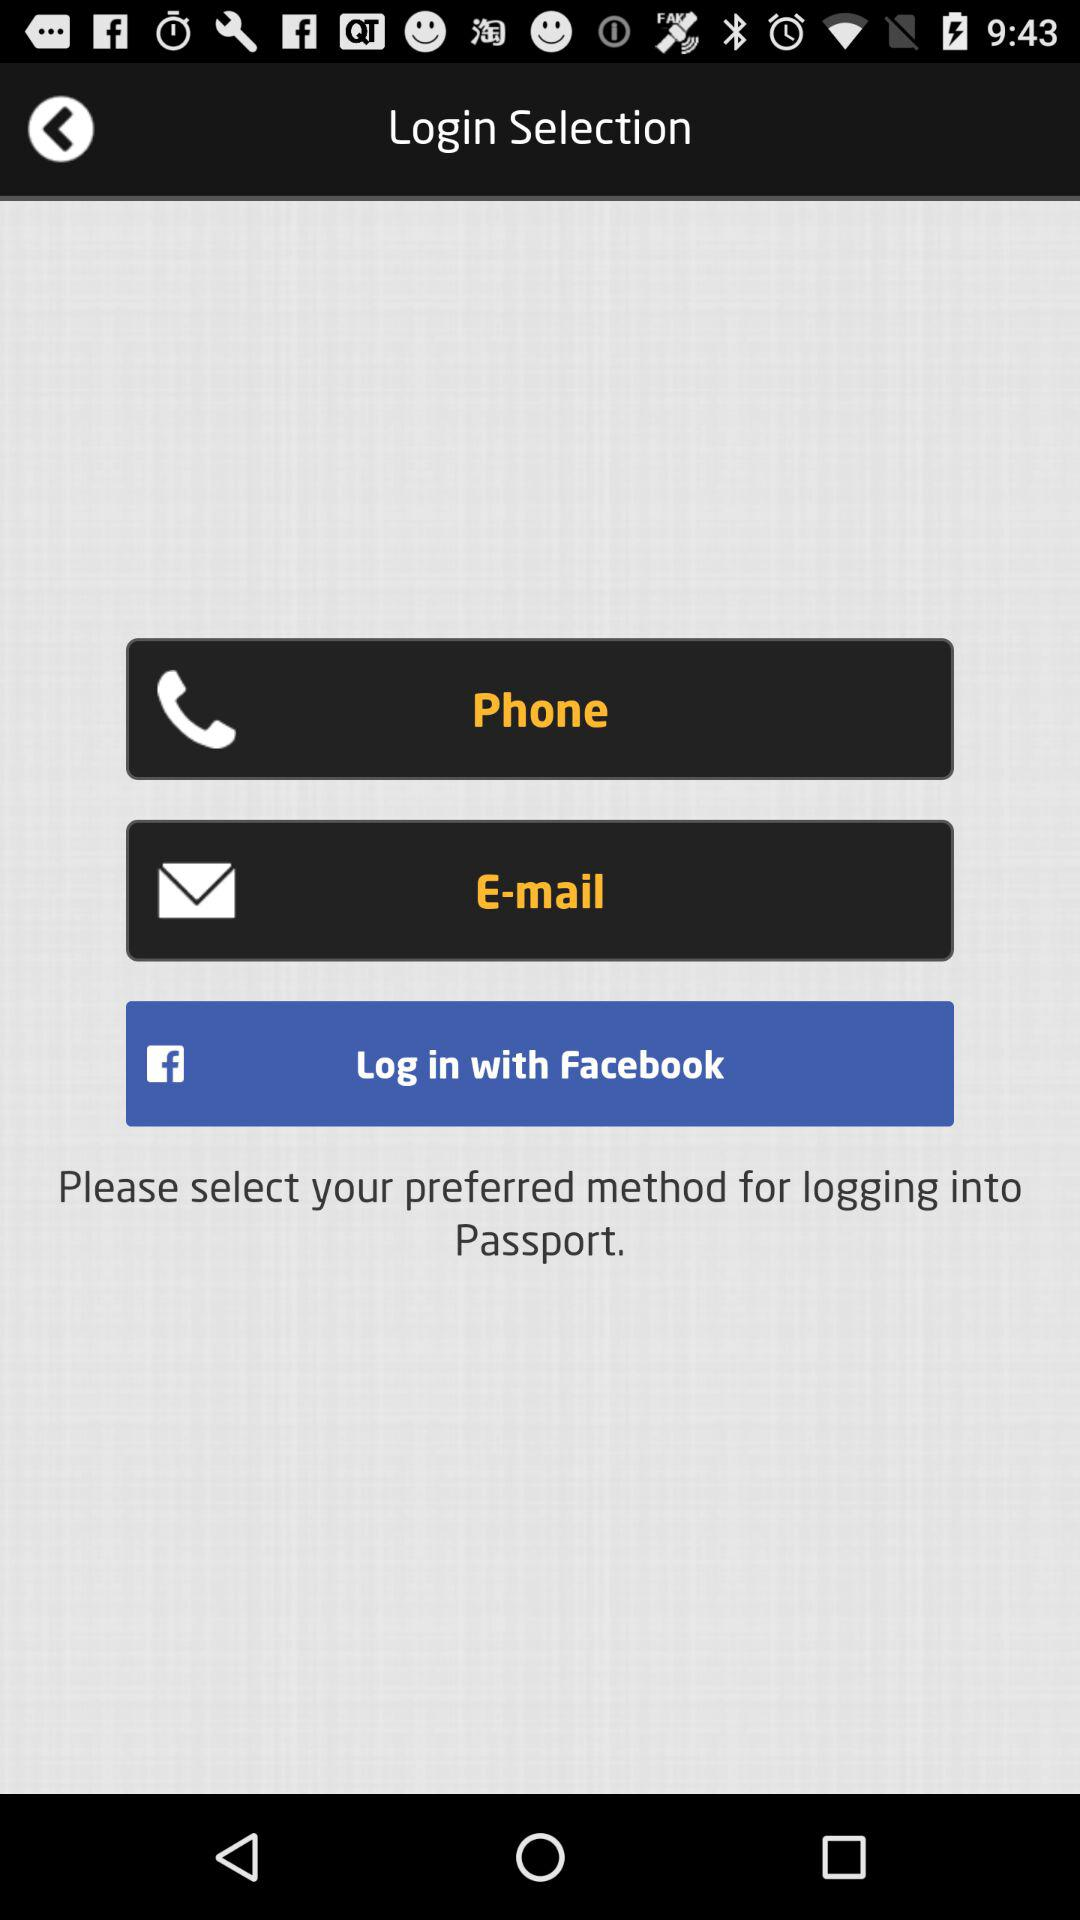What is the email address?
When the provided information is insufficient, respond with <no answer>. <no answer> 